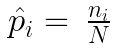Convert formula to latex. <formula><loc_0><loc_0><loc_500><loc_500>\begin{array} { r l } \hat { p } _ { i } = & \frac { n _ { i } } { N } \end{array}</formula> 